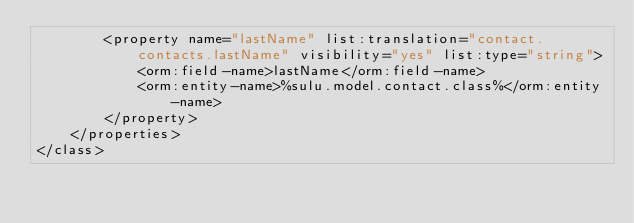Convert code to text. <code><loc_0><loc_0><loc_500><loc_500><_XML_>        <property name="lastName" list:translation="contact.contacts.lastName" visibility="yes" list:type="string">
            <orm:field-name>lastName</orm:field-name>
            <orm:entity-name>%sulu.model.contact.class%</orm:entity-name>
        </property>
    </properties>
</class>
</code> 